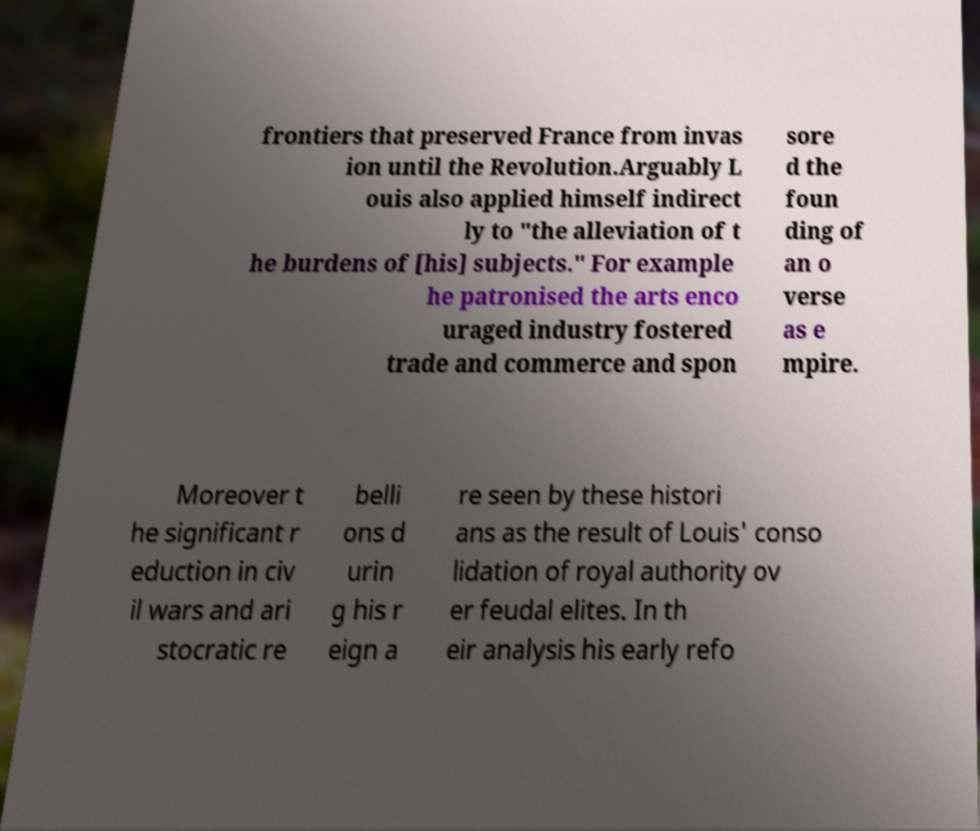What messages or text are displayed in this image? I need them in a readable, typed format. frontiers that preserved France from invas ion until the Revolution.Arguably L ouis also applied himself indirect ly to "the alleviation of t he burdens of [his] subjects." For example he patronised the arts enco uraged industry fostered trade and commerce and spon sore d the foun ding of an o verse as e mpire. Moreover t he significant r eduction in civ il wars and ari stocratic re belli ons d urin g his r eign a re seen by these histori ans as the result of Louis' conso lidation of royal authority ov er feudal elites. In th eir analysis his early refo 